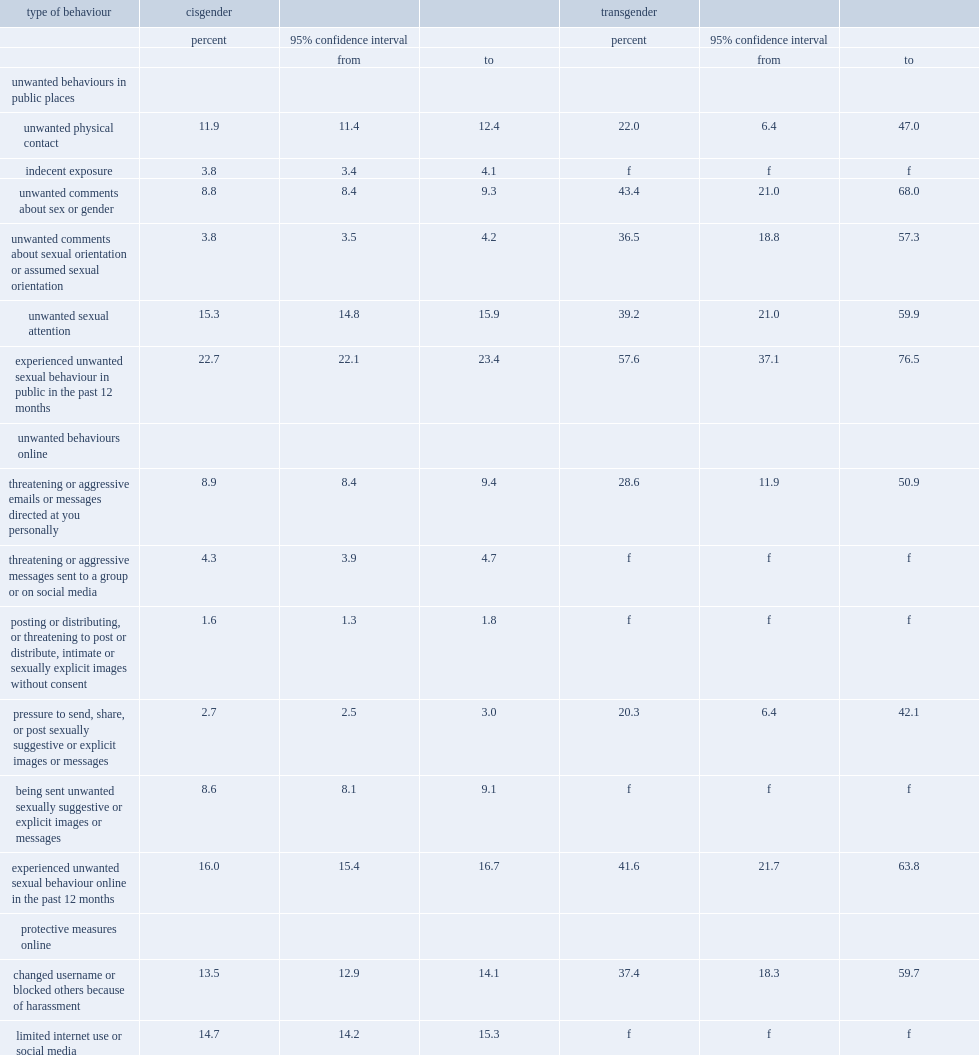Which group of people has a larger proportion of people reporting that they had experienced an unwanted sexual behaviour while in public in the 12 months? transgender canadians or cisgender canadians? Transgender. Which group of people were more likely to change their username or block others as a result of harassment they had experienced online? transgender or cisgender people? Transgender. 